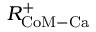Convert formula to latex. <formula><loc_0><loc_0><loc_500><loc_500>R _ { C o M - C a } ^ { + }</formula> 